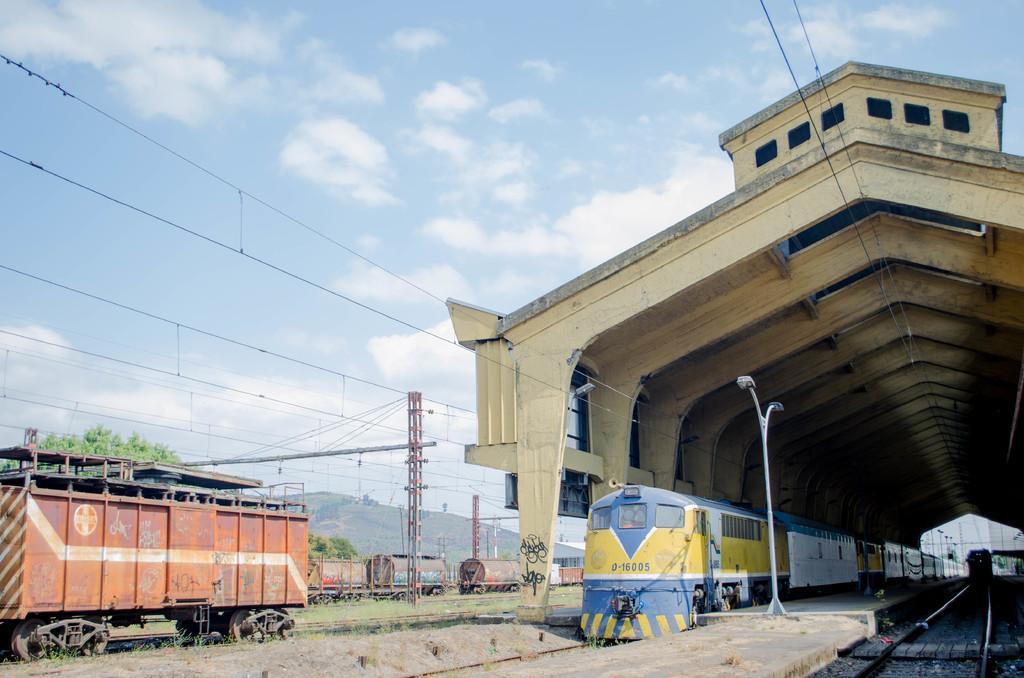In one or two sentences, can you explain what this image depicts? In this image I can see few railway tracks and on it I can see trains. I can also see few poles, wires, trees, a tunnel, clouds and the sky. 